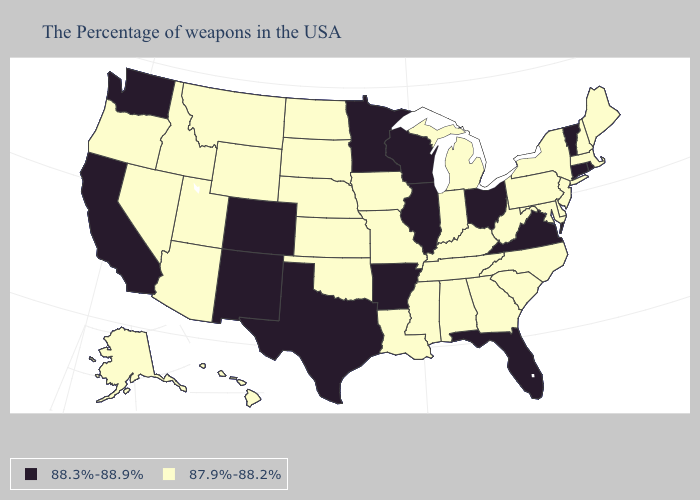Does Alabama have the lowest value in the South?
Keep it brief. Yes. Name the states that have a value in the range 88.3%-88.9%?
Keep it brief. Rhode Island, Vermont, Connecticut, Virginia, Ohio, Florida, Wisconsin, Illinois, Arkansas, Minnesota, Texas, Colorado, New Mexico, California, Washington. What is the highest value in the USA?
Quick response, please. 88.3%-88.9%. Does Maine have the same value as Louisiana?
Give a very brief answer. Yes. Name the states that have a value in the range 87.9%-88.2%?
Keep it brief. Maine, Massachusetts, New Hampshire, New York, New Jersey, Delaware, Maryland, Pennsylvania, North Carolina, South Carolina, West Virginia, Georgia, Michigan, Kentucky, Indiana, Alabama, Tennessee, Mississippi, Louisiana, Missouri, Iowa, Kansas, Nebraska, Oklahoma, South Dakota, North Dakota, Wyoming, Utah, Montana, Arizona, Idaho, Nevada, Oregon, Alaska, Hawaii. Which states hav the highest value in the MidWest?
Keep it brief. Ohio, Wisconsin, Illinois, Minnesota. What is the lowest value in the West?
Answer briefly. 87.9%-88.2%. Among the states that border Rhode Island , does Massachusetts have the lowest value?
Concise answer only. Yes. What is the highest value in the USA?
Write a very short answer. 88.3%-88.9%. How many symbols are there in the legend?
Be succinct. 2. Name the states that have a value in the range 87.9%-88.2%?
Quick response, please. Maine, Massachusetts, New Hampshire, New York, New Jersey, Delaware, Maryland, Pennsylvania, North Carolina, South Carolina, West Virginia, Georgia, Michigan, Kentucky, Indiana, Alabama, Tennessee, Mississippi, Louisiana, Missouri, Iowa, Kansas, Nebraska, Oklahoma, South Dakota, North Dakota, Wyoming, Utah, Montana, Arizona, Idaho, Nevada, Oregon, Alaska, Hawaii. Name the states that have a value in the range 88.3%-88.9%?
Write a very short answer. Rhode Island, Vermont, Connecticut, Virginia, Ohio, Florida, Wisconsin, Illinois, Arkansas, Minnesota, Texas, Colorado, New Mexico, California, Washington. What is the value of Oklahoma?
Short answer required. 87.9%-88.2%. Among the states that border Missouri , does Arkansas have the highest value?
Quick response, please. Yes. 